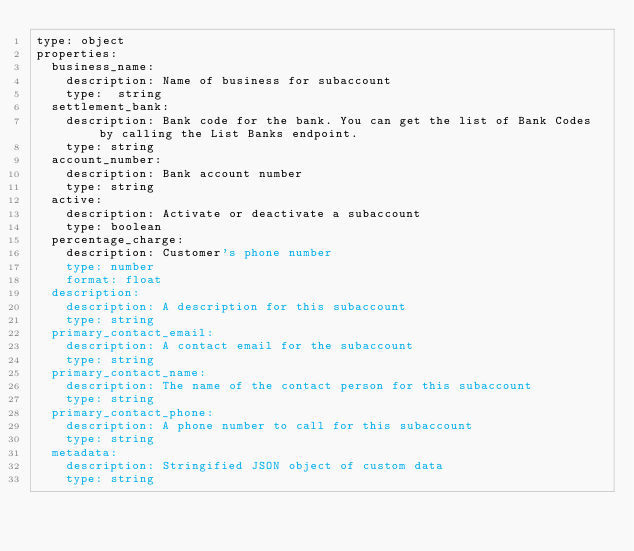<code> <loc_0><loc_0><loc_500><loc_500><_YAML_>type: object
properties:
  business_name:
    description: Name of business for subaccount
    type:  string
  settlement_bank:
    description: Bank code for the bank. You can get the list of Bank Codes by calling the List Banks endpoint.
    type: string
  account_number:
    description: Bank account number
    type: string
  active:
    description: Activate or deactivate a subaccount
    type: boolean
  percentage_charge:
    description: Customer's phone number
    type: number
    format: float
  description:
    description: A description for this subaccount
    type: string
  primary_contact_email:
    description: A contact email for the subaccount
    type: string
  primary_contact_name:
    description: The name of the contact person for this subaccount
    type: string
  primary_contact_phone:
    description: A phone number to call for this subaccount
    type: string
  metadata:
    description: Stringified JSON object of custom data
    type: string</code> 